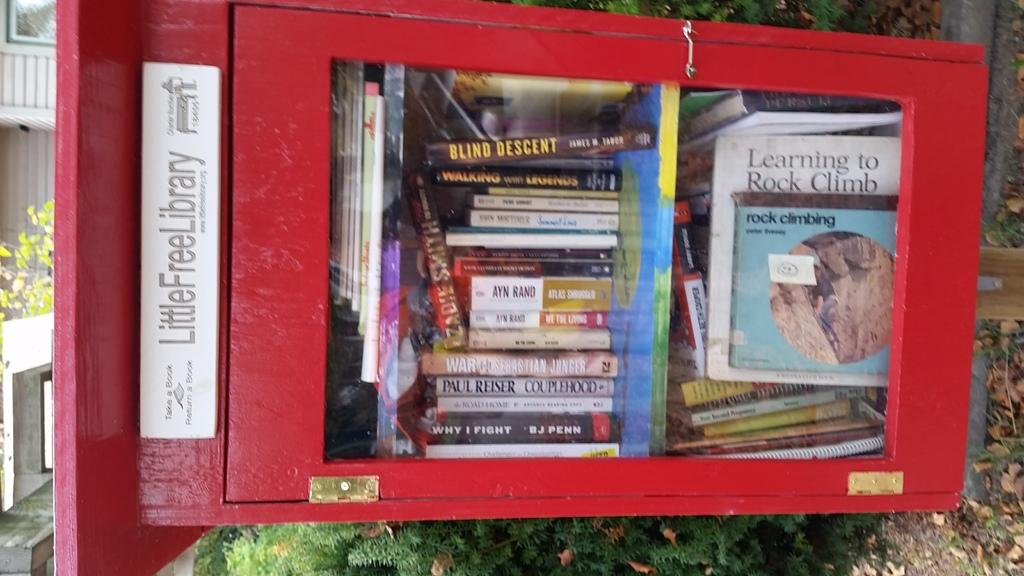Provide a one-sentence caption for the provided image. A little free library includes a book called Blind Descent. 